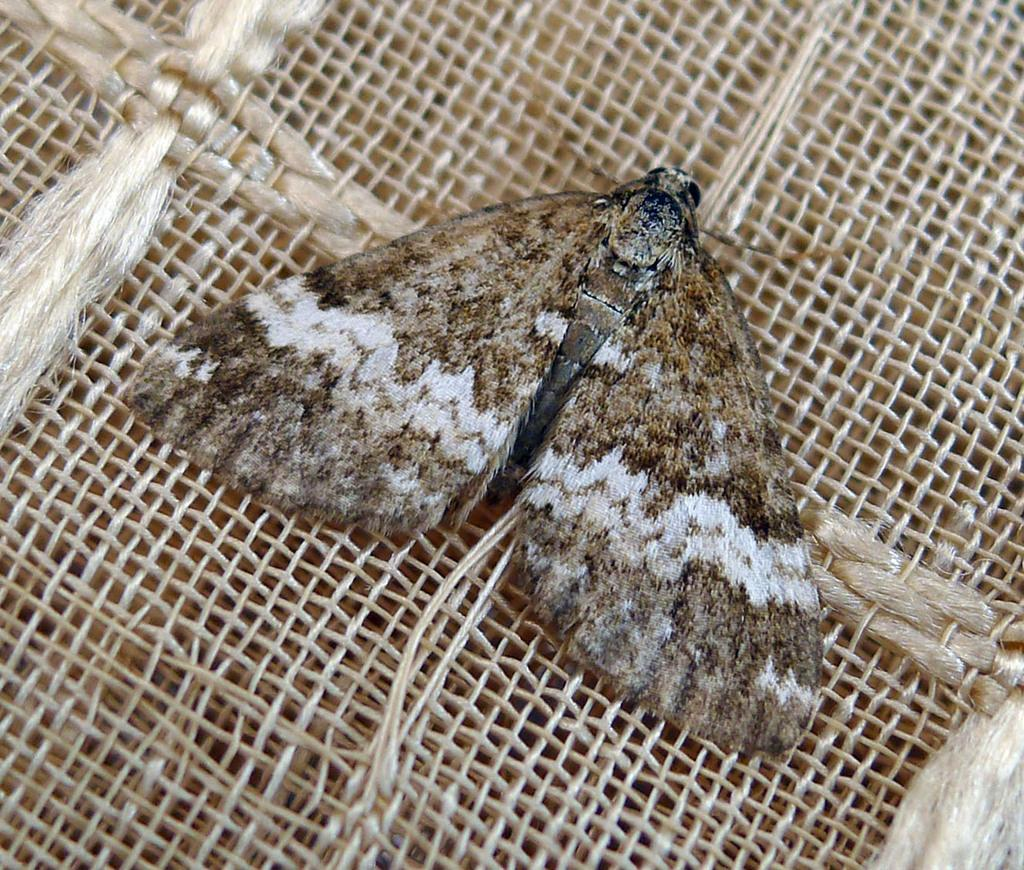What is present in the image? There is an insect in the image. Where is the insect located? The insect is on a jute mat. What is the name of the son of the insect in the image? There is no son of the insect present in the image, as insects do not have offspring in the same way as mammals. 